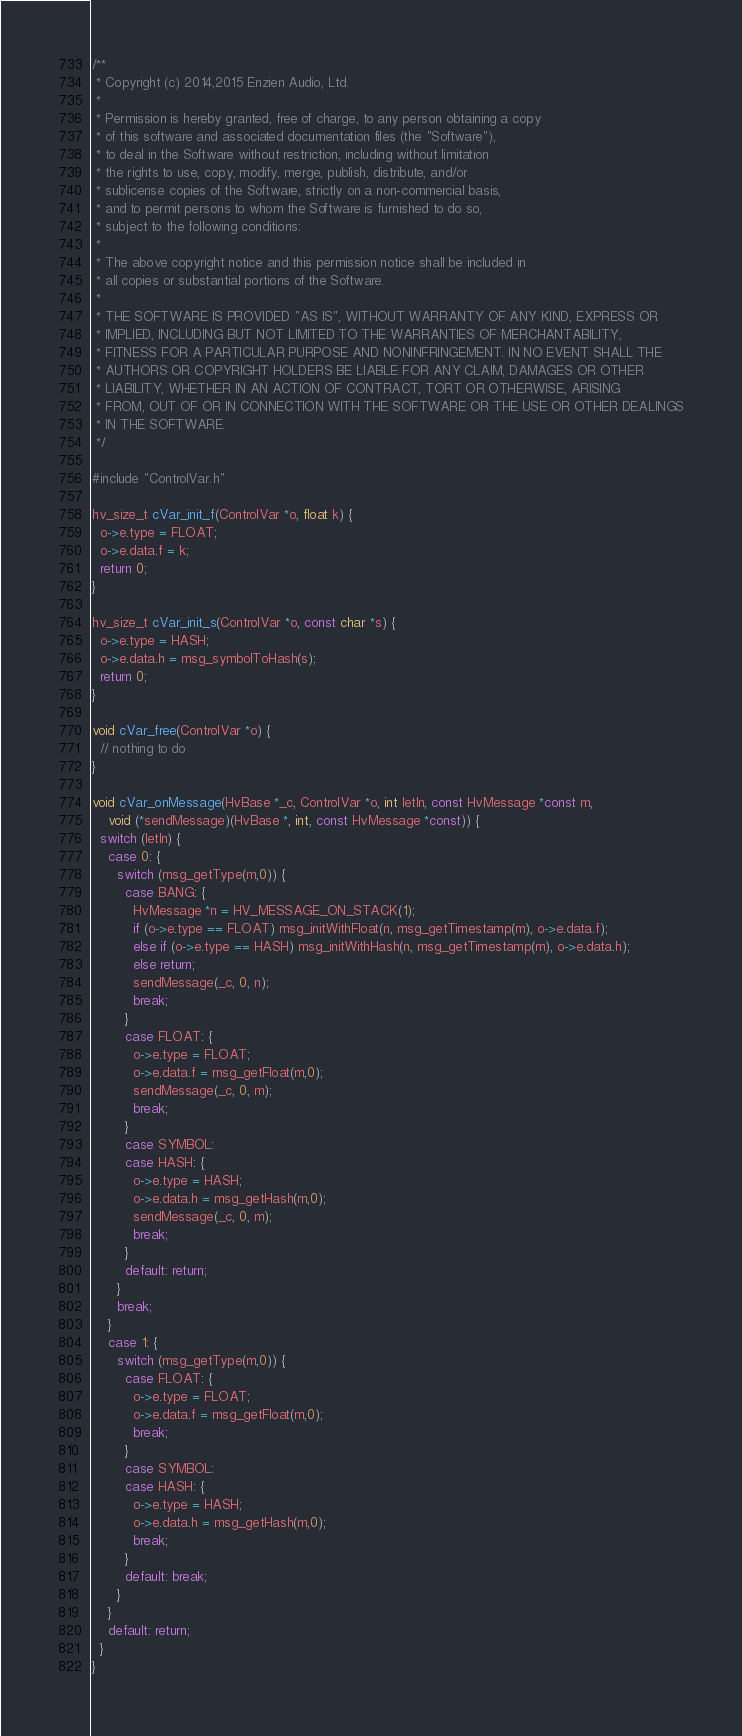<code> <loc_0><loc_0><loc_500><loc_500><_C_>/**
 * Copyright (c) 2014,2015 Enzien Audio, Ltd.
 *
 * Permission is hereby granted, free of charge, to any person obtaining a copy
 * of this software and associated documentation files (the "Software"),
 * to deal in the Software without restriction, including without limitation
 * the rights to use, copy, modify, merge, publish, distribute, and/or
 * sublicense copies of the Software, strictly on a non-commercial basis,
 * and to permit persons to whom the Software is furnished to do so,
 * subject to the following conditions:
 *
 * The above copyright notice and this permission notice shall be included in
 * all copies or substantial portions of the Software.
 *
 * THE SOFTWARE IS PROVIDED "AS IS", WITHOUT WARRANTY OF ANY KIND, EXPRESS OR
 * IMPLIED, INCLUDING BUT NOT LIMITED TO THE WARRANTIES OF MERCHANTABILITY,
 * FITNESS FOR A PARTICULAR PURPOSE AND NONINFRINGEMENT. IN NO EVENT SHALL THE
 * AUTHORS OR COPYRIGHT HOLDERS BE LIABLE FOR ANY CLAIM, DAMAGES OR OTHER
 * LIABILITY, WHETHER IN AN ACTION OF CONTRACT, TORT OR OTHERWISE, ARISING
 * FROM, OUT OF OR IN CONNECTION WITH THE SOFTWARE OR THE USE OR OTHER DEALINGS
 * IN THE SOFTWARE.
 */

#include "ControlVar.h"

hv_size_t cVar_init_f(ControlVar *o, float k) {
  o->e.type = FLOAT;
  o->e.data.f = k;
  return 0;
}

hv_size_t cVar_init_s(ControlVar *o, const char *s) {
  o->e.type = HASH;
  o->e.data.h = msg_symbolToHash(s);
  return 0;
}

void cVar_free(ControlVar *o) {
  // nothing to do
}

void cVar_onMessage(HvBase *_c, ControlVar *o, int letIn, const HvMessage *const m,
    void (*sendMessage)(HvBase *, int, const HvMessage *const)) {
  switch (letIn) {
    case 0: {
      switch (msg_getType(m,0)) {
        case BANG: {
          HvMessage *n = HV_MESSAGE_ON_STACK(1);
          if (o->e.type == FLOAT) msg_initWithFloat(n, msg_getTimestamp(m), o->e.data.f);
          else if (o->e.type == HASH) msg_initWithHash(n, msg_getTimestamp(m), o->e.data.h);
          else return;
          sendMessage(_c, 0, n);
          break;
        }
        case FLOAT: {
          o->e.type = FLOAT;
          o->e.data.f = msg_getFloat(m,0);
          sendMessage(_c, 0, m);
          break;
        }
        case SYMBOL:
        case HASH: {
          o->e.type = HASH;
          o->e.data.h = msg_getHash(m,0);
          sendMessage(_c, 0, m);
          break;
        }
        default: return;
      }
      break;
    }
    case 1: {
      switch (msg_getType(m,0)) {
        case FLOAT: {
          o->e.type = FLOAT;
          o->e.data.f = msg_getFloat(m,0);
          break;
        }
        case SYMBOL:
        case HASH: {
          o->e.type = HASH;
          o->e.data.h = msg_getHash(m,0);
          break;
        }
        default: break;
      }
    }
    default: return;
  }
}
</code> 